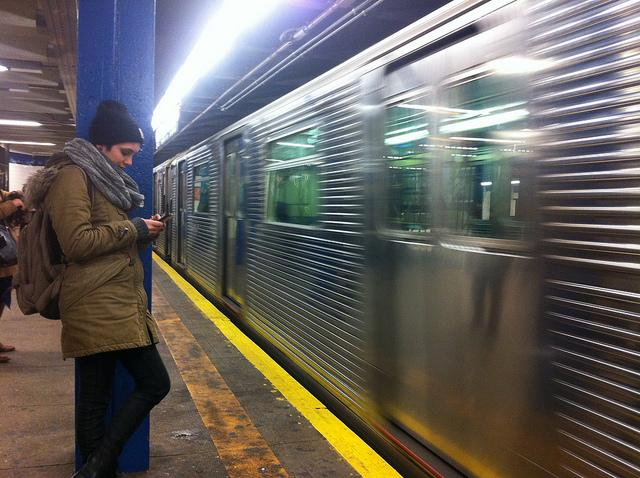What type of communication is she using? cellphone 